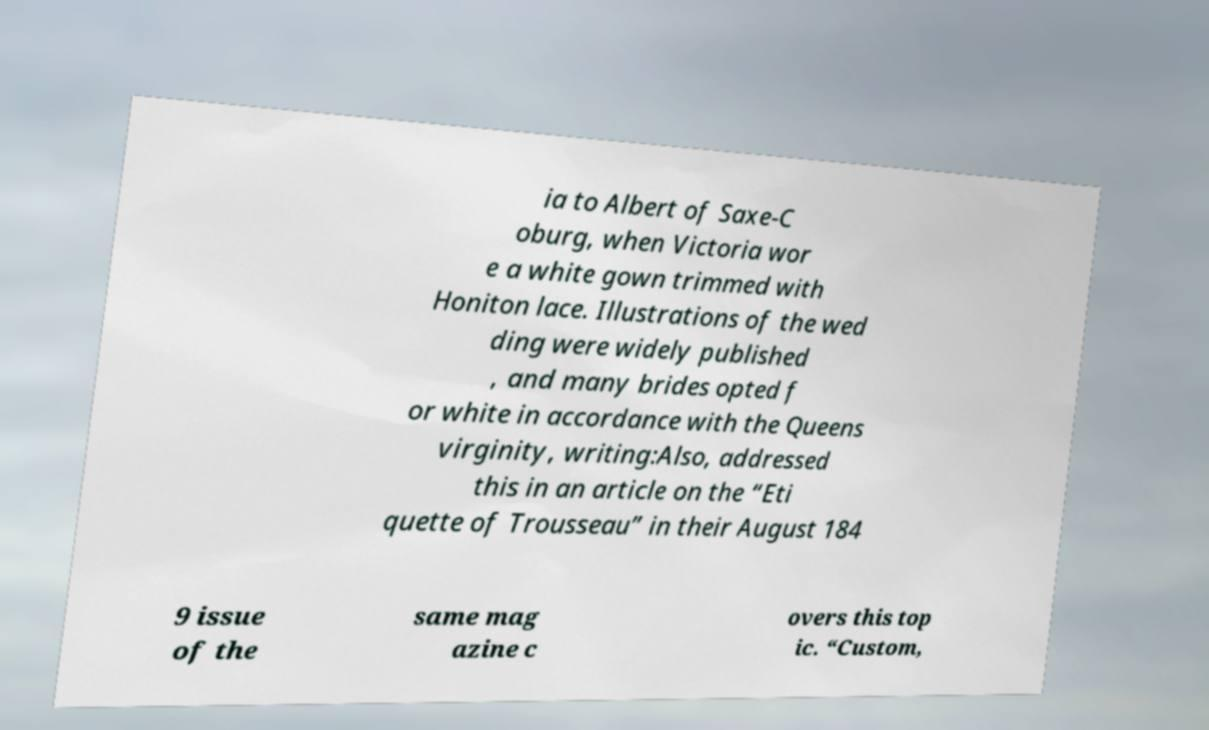Please identify and transcribe the text found in this image. ia to Albert of Saxe-C oburg, when Victoria wor e a white gown trimmed with Honiton lace. Illustrations of the wed ding were widely published , and many brides opted f or white in accordance with the Queens virginity, writing:Also, addressed this in an article on the “Eti quette of Trousseau” in their August 184 9 issue of the same mag azine c overs this top ic. “Custom, 